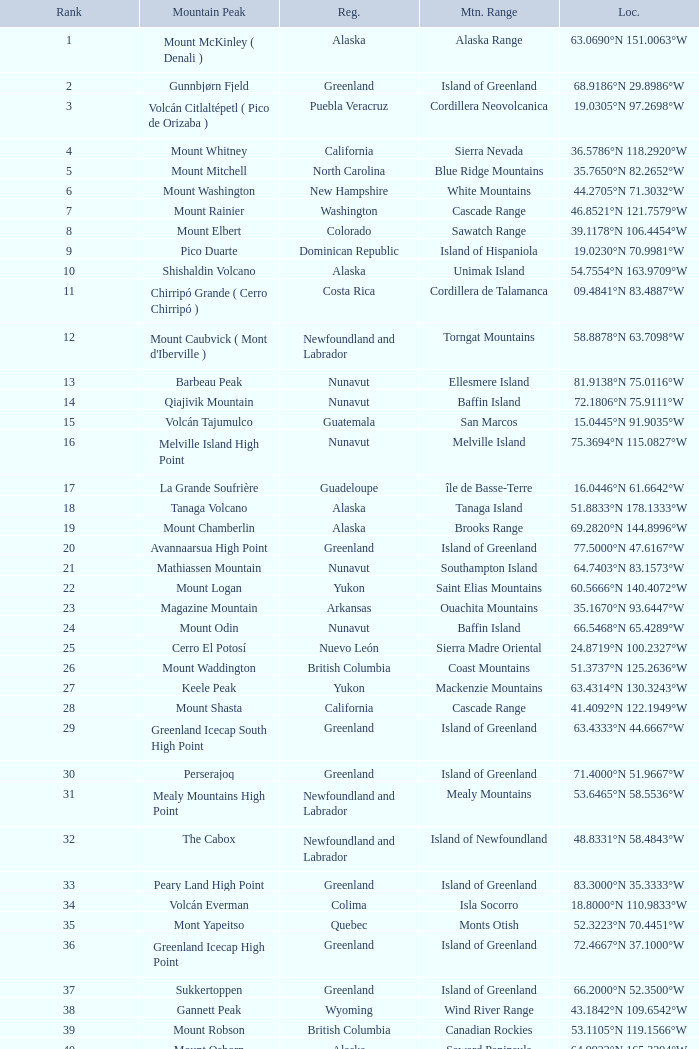Which Mountain Range has a Region of haiti, and a Location of 18.3601°n 71.9764°w? Island of Hispaniola. 